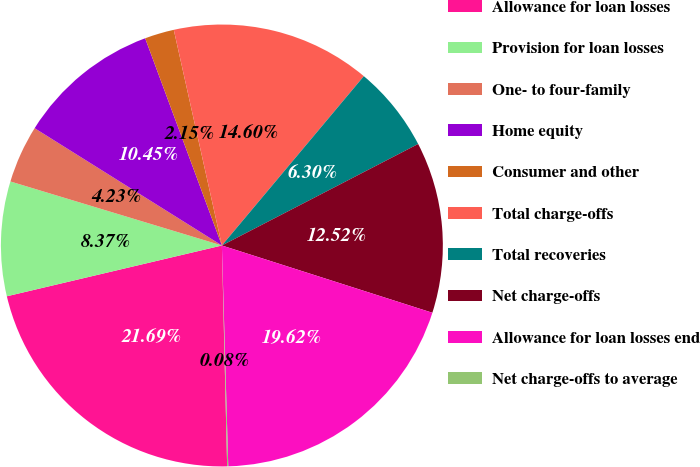Convert chart to OTSL. <chart><loc_0><loc_0><loc_500><loc_500><pie_chart><fcel>Allowance for loan losses<fcel>Provision for loan losses<fcel>One- to four-family<fcel>Home equity<fcel>Consumer and other<fcel>Total charge-offs<fcel>Total recoveries<fcel>Net charge-offs<fcel>Allowance for loan losses end<fcel>Net charge-offs to average<nl><fcel>21.69%<fcel>8.37%<fcel>4.23%<fcel>10.45%<fcel>2.15%<fcel>14.6%<fcel>6.3%<fcel>12.52%<fcel>19.62%<fcel>0.08%<nl></chart> 